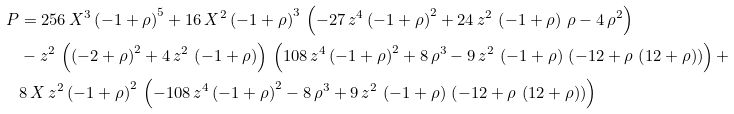<formula> <loc_0><loc_0><loc_500><loc_500>P & = 2 5 6 \, X ^ { 3 } \, { \left ( - 1 + \rho \right ) } ^ { 5 } + 1 6 \, X ^ { 2 } \, { \left ( - 1 + \rho \right ) } ^ { 3 } \, \left ( - 2 7 \, z ^ { 4 } \, { \left ( - 1 + \rho \right ) } ^ { 2 } + 2 4 \, z ^ { 2 } \, \left ( - 1 + \rho \right ) \, \rho - 4 \, { \rho } ^ { 2 } \right ) \\ & - z ^ { 2 } \, \left ( { \left ( - 2 + \rho \right ) } ^ { 2 } + 4 \, z ^ { 2 } \, \left ( - 1 + \rho \right ) \right ) \, \left ( 1 0 8 \, z ^ { 4 } \, { \left ( - 1 + \rho \right ) } ^ { 2 } + 8 \, { \rho } ^ { 3 } - 9 \, z ^ { 2 } \, \left ( - 1 + \rho \right ) \, \left ( - 1 2 + \rho \, \left ( 1 2 + \rho \right ) \right ) \right ) + \\ & 8 \, X \, z ^ { 2 } \, { \left ( - 1 + \rho \right ) } ^ { 2 } \, \left ( - 1 0 8 \, z ^ { 4 } \, { \left ( - 1 + \rho \right ) } ^ { 2 } - 8 \, { \rho } ^ { 3 } + 9 \, z ^ { 2 } \, \left ( - 1 + \rho \right ) \, \left ( - 1 2 + \rho \, \left ( 1 2 + \rho \right ) \right ) \right )</formula> 